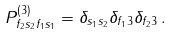<formula> <loc_0><loc_0><loc_500><loc_500>P _ { f _ { 2 } s _ { 2 } f _ { 1 } s _ { 1 } } ^ { ( 3 ) } = \delta _ { s _ { 1 } s _ { 2 } } \delta _ { f _ { 1 } 3 } \delta _ { f _ { 2 } 3 } \, .</formula> 